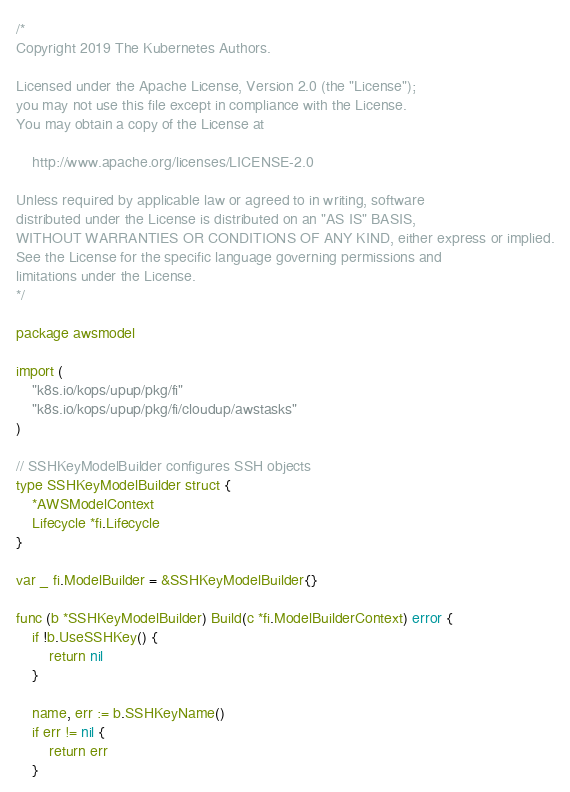Convert code to text. <code><loc_0><loc_0><loc_500><loc_500><_Go_>/*
Copyright 2019 The Kubernetes Authors.

Licensed under the Apache License, Version 2.0 (the "License");
you may not use this file except in compliance with the License.
You may obtain a copy of the License at

    http://www.apache.org/licenses/LICENSE-2.0

Unless required by applicable law or agreed to in writing, software
distributed under the License is distributed on an "AS IS" BASIS,
WITHOUT WARRANTIES OR CONDITIONS OF ANY KIND, either express or implied.
See the License for the specific language governing permissions and
limitations under the License.
*/

package awsmodel

import (
	"k8s.io/kops/upup/pkg/fi"
	"k8s.io/kops/upup/pkg/fi/cloudup/awstasks"
)

// SSHKeyModelBuilder configures SSH objects
type SSHKeyModelBuilder struct {
	*AWSModelContext
	Lifecycle *fi.Lifecycle
}

var _ fi.ModelBuilder = &SSHKeyModelBuilder{}

func (b *SSHKeyModelBuilder) Build(c *fi.ModelBuilderContext) error {
	if !b.UseSSHKey() {
		return nil
	}

	name, err := b.SSHKeyName()
	if err != nil {
		return err
	}</code> 